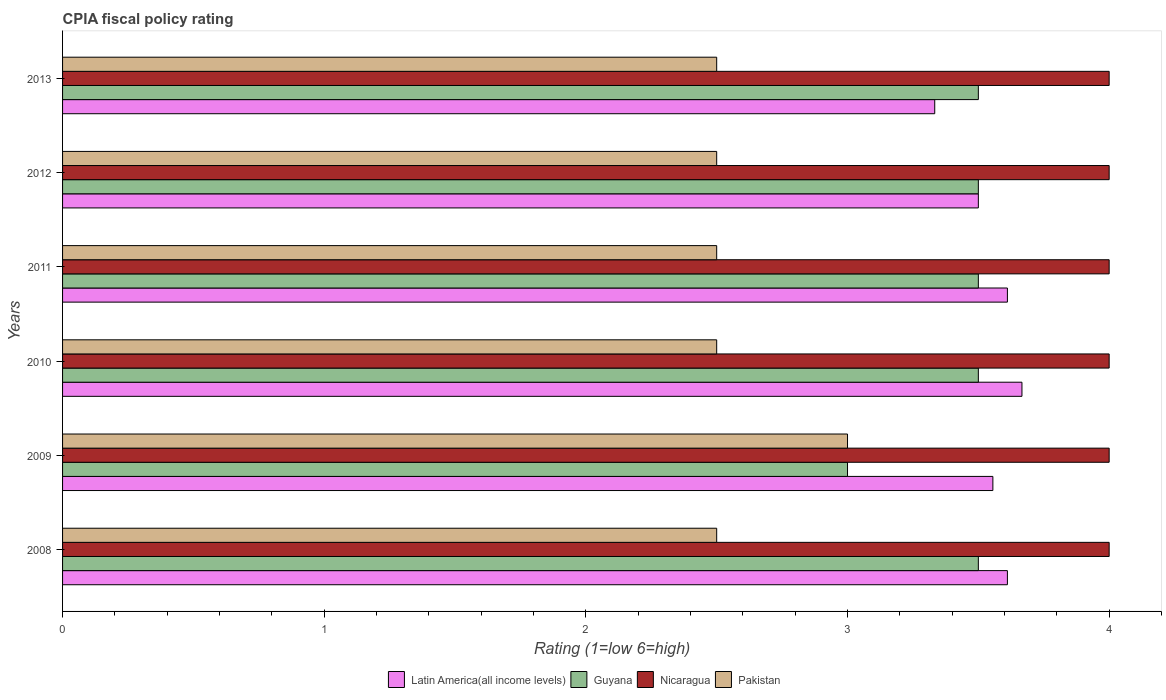Are the number of bars on each tick of the Y-axis equal?
Your response must be concise. Yes. How many bars are there on the 5th tick from the top?
Provide a short and direct response. 4. What is the label of the 4th group of bars from the top?
Provide a succinct answer. 2010. What is the CPIA rating in Guyana in 2010?
Provide a succinct answer. 3.5. Across all years, what is the minimum CPIA rating in Guyana?
Provide a short and direct response. 3. In which year was the CPIA rating in Pakistan maximum?
Offer a very short reply. 2009. In which year was the CPIA rating in Latin America(all income levels) minimum?
Offer a terse response. 2013. What is the difference between the CPIA rating in Nicaragua in 2008 and that in 2011?
Provide a succinct answer. 0. What is the difference between the CPIA rating in Latin America(all income levels) in 2009 and the CPIA rating in Pakistan in 2012?
Offer a terse response. 1.06. What is the average CPIA rating in Pakistan per year?
Your response must be concise. 2.58. In the year 2013, what is the difference between the CPIA rating in Guyana and CPIA rating in Pakistan?
Provide a short and direct response. 1. Is the CPIA rating in Guyana in 2009 less than that in 2011?
Keep it short and to the point. Yes. What is the difference between the highest and the second highest CPIA rating in Pakistan?
Offer a very short reply. 0.5. In how many years, is the CPIA rating in Nicaragua greater than the average CPIA rating in Nicaragua taken over all years?
Offer a terse response. 0. What does the 4th bar from the top in 2010 represents?
Make the answer very short. Latin America(all income levels). What does the 3rd bar from the bottom in 2013 represents?
Your response must be concise. Nicaragua. How many bars are there?
Your answer should be very brief. 24. Are all the bars in the graph horizontal?
Give a very brief answer. Yes. How many years are there in the graph?
Provide a short and direct response. 6. What is the difference between two consecutive major ticks on the X-axis?
Your answer should be compact. 1. Does the graph contain any zero values?
Offer a very short reply. No. Does the graph contain grids?
Your answer should be very brief. No. Where does the legend appear in the graph?
Offer a very short reply. Bottom center. How many legend labels are there?
Provide a succinct answer. 4. How are the legend labels stacked?
Provide a succinct answer. Horizontal. What is the title of the graph?
Your response must be concise. CPIA fiscal policy rating. Does "Dominican Republic" appear as one of the legend labels in the graph?
Your response must be concise. No. What is the label or title of the X-axis?
Your answer should be very brief. Rating (1=low 6=high). What is the Rating (1=low 6=high) of Latin America(all income levels) in 2008?
Your answer should be very brief. 3.61. What is the Rating (1=low 6=high) of Guyana in 2008?
Your answer should be compact. 3.5. What is the Rating (1=low 6=high) in Nicaragua in 2008?
Your response must be concise. 4. What is the Rating (1=low 6=high) in Pakistan in 2008?
Offer a very short reply. 2.5. What is the Rating (1=low 6=high) in Latin America(all income levels) in 2009?
Your response must be concise. 3.56. What is the Rating (1=low 6=high) of Guyana in 2009?
Provide a succinct answer. 3. What is the Rating (1=low 6=high) in Latin America(all income levels) in 2010?
Offer a very short reply. 3.67. What is the Rating (1=low 6=high) in Latin America(all income levels) in 2011?
Make the answer very short. 3.61. What is the Rating (1=low 6=high) in Guyana in 2011?
Provide a short and direct response. 3.5. What is the Rating (1=low 6=high) of Nicaragua in 2011?
Your response must be concise. 4. What is the Rating (1=low 6=high) in Pakistan in 2011?
Your answer should be compact. 2.5. What is the Rating (1=low 6=high) of Latin America(all income levels) in 2012?
Give a very brief answer. 3.5. What is the Rating (1=low 6=high) of Latin America(all income levels) in 2013?
Keep it short and to the point. 3.33. What is the Rating (1=low 6=high) in Guyana in 2013?
Ensure brevity in your answer.  3.5. What is the Rating (1=low 6=high) in Nicaragua in 2013?
Offer a very short reply. 4. What is the Rating (1=low 6=high) of Pakistan in 2013?
Make the answer very short. 2.5. Across all years, what is the maximum Rating (1=low 6=high) of Latin America(all income levels)?
Offer a terse response. 3.67. Across all years, what is the minimum Rating (1=low 6=high) of Latin America(all income levels)?
Provide a succinct answer. 3.33. Across all years, what is the minimum Rating (1=low 6=high) in Guyana?
Provide a short and direct response. 3. Across all years, what is the minimum Rating (1=low 6=high) of Nicaragua?
Provide a succinct answer. 4. Across all years, what is the minimum Rating (1=low 6=high) of Pakistan?
Ensure brevity in your answer.  2.5. What is the total Rating (1=low 6=high) of Latin America(all income levels) in the graph?
Give a very brief answer. 21.28. What is the difference between the Rating (1=low 6=high) in Latin America(all income levels) in 2008 and that in 2009?
Your answer should be compact. 0.06. What is the difference between the Rating (1=low 6=high) in Guyana in 2008 and that in 2009?
Provide a succinct answer. 0.5. What is the difference between the Rating (1=low 6=high) in Pakistan in 2008 and that in 2009?
Provide a succinct answer. -0.5. What is the difference between the Rating (1=low 6=high) of Latin America(all income levels) in 2008 and that in 2010?
Ensure brevity in your answer.  -0.06. What is the difference between the Rating (1=low 6=high) in Guyana in 2008 and that in 2010?
Your answer should be very brief. 0. What is the difference between the Rating (1=low 6=high) in Pakistan in 2008 and that in 2010?
Your response must be concise. 0. What is the difference between the Rating (1=low 6=high) in Latin America(all income levels) in 2008 and that in 2011?
Provide a succinct answer. 0. What is the difference between the Rating (1=low 6=high) of Latin America(all income levels) in 2008 and that in 2012?
Make the answer very short. 0.11. What is the difference between the Rating (1=low 6=high) of Guyana in 2008 and that in 2012?
Give a very brief answer. 0. What is the difference between the Rating (1=low 6=high) of Nicaragua in 2008 and that in 2012?
Your answer should be very brief. 0. What is the difference between the Rating (1=low 6=high) of Pakistan in 2008 and that in 2012?
Ensure brevity in your answer.  0. What is the difference between the Rating (1=low 6=high) in Latin America(all income levels) in 2008 and that in 2013?
Keep it short and to the point. 0.28. What is the difference between the Rating (1=low 6=high) of Nicaragua in 2008 and that in 2013?
Provide a succinct answer. 0. What is the difference between the Rating (1=low 6=high) in Latin America(all income levels) in 2009 and that in 2010?
Make the answer very short. -0.11. What is the difference between the Rating (1=low 6=high) in Pakistan in 2009 and that in 2010?
Keep it short and to the point. 0.5. What is the difference between the Rating (1=low 6=high) in Latin America(all income levels) in 2009 and that in 2011?
Ensure brevity in your answer.  -0.06. What is the difference between the Rating (1=low 6=high) in Guyana in 2009 and that in 2011?
Your answer should be very brief. -0.5. What is the difference between the Rating (1=low 6=high) of Nicaragua in 2009 and that in 2011?
Offer a very short reply. 0. What is the difference between the Rating (1=low 6=high) of Pakistan in 2009 and that in 2011?
Offer a very short reply. 0.5. What is the difference between the Rating (1=low 6=high) of Latin America(all income levels) in 2009 and that in 2012?
Provide a succinct answer. 0.06. What is the difference between the Rating (1=low 6=high) of Guyana in 2009 and that in 2012?
Ensure brevity in your answer.  -0.5. What is the difference between the Rating (1=low 6=high) of Nicaragua in 2009 and that in 2012?
Provide a short and direct response. 0. What is the difference between the Rating (1=low 6=high) of Pakistan in 2009 and that in 2012?
Make the answer very short. 0.5. What is the difference between the Rating (1=low 6=high) of Latin America(all income levels) in 2009 and that in 2013?
Provide a short and direct response. 0.22. What is the difference between the Rating (1=low 6=high) in Guyana in 2009 and that in 2013?
Offer a terse response. -0.5. What is the difference between the Rating (1=low 6=high) in Nicaragua in 2009 and that in 2013?
Keep it short and to the point. 0. What is the difference between the Rating (1=low 6=high) of Pakistan in 2009 and that in 2013?
Provide a short and direct response. 0.5. What is the difference between the Rating (1=low 6=high) in Latin America(all income levels) in 2010 and that in 2011?
Provide a succinct answer. 0.06. What is the difference between the Rating (1=low 6=high) in Guyana in 2010 and that in 2011?
Offer a terse response. 0. What is the difference between the Rating (1=low 6=high) of Nicaragua in 2010 and that in 2011?
Offer a very short reply. 0. What is the difference between the Rating (1=low 6=high) of Latin America(all income levels) in 2010 and that in 2012?
Your response must be concise. 0.17. What is the difference between the Rating (1=low 6=high) of Nicaragua in 2010 and that in 2012?
Offer a terse response. 0. What is the difference between the Rating (1=low 6=high) of Guyana in 2010 and that in 2013?
Your answer should be compact. 0. What is the difference between the Rating (1=low 6=high) of Nicaragua in 2010 and that in 2013?
Make the answer very short. 0. What is the difference between the Rating (1=low 6=high) in Latin America(all income levels) in 2011 and that in 2012?
Your answer should be compact. 0.11. What is the difference between the Rating (1=low 6=high) of Guyana in 2011 and that in 2012?
Make the answer very short. 0. What is the difference between the Rating (1=low 6=high) of Pakistan in 2011 and that in 2012?
Provide a succinct answer. 0. What is the difference between the Rating (1=low 6=high) of Latin America(all income levels) in 2011 and that in 2013?
Your answer should be compact. 0.28. What is the difference between the Rating (1=low 6=high) in Guyana in 2011 and that in 2013?
Provide a short and direct response. 0. What is the difference between the Rating (1=low 6=high) in Pakistan in 2011 and that in 2013?
Keep it short and to the point. 0. What is the difference between the Rating (1=low 6=high) in Latin America(all income levels) in 2012 and that in 2013?
Make the answer very short. 0.17. What is the difference between the Rating (1=low 6=high) of Guyana in 2012 and that in 2013?
Ensure brevity in your answer.  0. What is the difference between the Rating (1=low 6=high) in Latin America(all income levels) in 2008 and the Rating (1=low 6=high) in Guyana in 2009?
Offer a very short reply. 0.61. What is the difference between the Rating (1=low 6=high) in Latin America(all income levels) in 2008 and the Rating (1=low 6=high) in Nicaragua in 2009?
Provide a short and direct response. -0.39. What is the difference between the Rating (1=low 6=high) in Latin America(all income levels) in 2008 and the Rating (1=low 6=high) in Pakistan in 2009?
Your answer should be compact. 0.61. What is the difference between the Rating (1=low 6=high) of Latin America(all income levels) in 2008 and the Rating (1=low 6=high) of Nicaragua in 2010?
Your answer should be very brief. -0.39. What is the difference between the Rating (1=low 6=high) of Latin America(all income levels) in 2008 and the Rating (1=low 6=high) of Pakistan in 2010?
Provide a short and direct response. 1.11. What is the difference between the Rating (1=low 6=high) of Nicaragua in 2008 and the Rating (1=low 6=high) of Pakistan in 2010?
Your answer should be very brief. 1.5. What is the difference between the Rating (1=low 6=high) of Latin America(all income levels) in 2008 and the Rating (1=low 6=high) of Guyana in 2011?
Your response must be concise. 0.11. What is the difference between the Rating (1=low 6=high) in Latin America(all income levels) in 2008 and the Rating (1=low 6=high) in Nicaragua in 2011?
Make the answer very short. -0.39. What is the difference between the Rating (1=low 6=high) in Latin America(all income levels) in 2008 and the Rating (1=low 6=high) in Pakistan in 2011?
Offer a terse response. 1.11. What is the difference between the Rating (1=low 6=high) of Latin America(all income levels) in 2008 and the Rating (1=low 6=high) of Guyana in 2012?
Offer a very short reply. 0.11. What is the difference between the Rating (1=low 6=high) in Latin America(all income levels) in 2008 and the Rating (1=low 6=high) in Nicaragua in 2012?
Provide a succinct answer. -0.39. What is the difference between the Rating (1=low 6=high) in Latin America(all income levels) in 2008 and the Rating (1=low 6=high) in Pakistan in 2012?
Provide a short and direct response. 1.11. What is the difference between the Rating (1=low 6=high) of Nicaragua in 2008 and the Rating (1=low 6=high) of Pakistan in 2012?
Your response must be concise. 1.5. What is the difference between the Rating (1=low 6=high) in Latin America(all income levels) in 2008 and the Rating (1=low 6=high) in Guyana in 2013?
Your response must be concise. 0.11. What is the difference between the Rating (1=low 6=high) in Latin America(all income levels) in 2008 and the Rating (1=low 6=high) in Nicaragua in 2013?
Offer a very short reply. -0.39. What is the difference between the Rating (1=low 6=high) in Latin America(all income levels) in 2008 and the Rating (1=low 6=high) in Pakistan in 2013?
Provide a succinct answer. 1.11. What is the difference between the Rating (1=low 6=high) of Latin America(all income levels) in 2009 and the Rating (1=low 6=high) of Guyana in 2010?
Keep it short and to the point. 0.06. What is the difference between the Rating (1=low 6=high) in Latin America(all income levels) in 2009 and the Rating (1=low 6=high) in Nicaragua in 2010?
Give a very brief answer. -0.44. What is the difference between the Rating (1=low 6=high) in Latin America(all income levels) in 2009 and the Rating (1=low 6=high) in Pakistan in 2010?
Your response must be concise. 1.06. What is the difference between the Rating (1=low 6=high) of Nicaragua in 2009 and the Rating (1=low 6=high) of Pakistan in 2010?
Offer a terse response. 1.5. What is the difference between the Rating (1=low 6=high) in Latin America(all income levels) in 2009 and the Rating (1=low 6=high) in Guyana in 2011?
Your response must be concise. 0.06. What is the difference between the Rating (1=low 6=high) of Latin America(all income levels) in 2009 and the Rating (1=low 6=high) of Nicaragua in 2011?
Your answer should be compact. -0.44. What is the difference between the Rating (1=low 6=high) of Latin America(all income levels) in 2009 and the Rating (1=low 6=high) of Pakistan in 2011?
Offer a terse response. 1.06. What is the difference between the Rating (1=low 6=high) in Guyana in 2009 and the Rating (1=low 6=high) in Pakistan in 2011?
Your answer should be very brief. 0.5. What is the difference between the Rating (1=low 6=high) of Nicaragua in 2009 and the Rating (1=low 6=high) of Pakistan in 2011?
Offer a terse response. 1.5. What is the difference between the Rating (1=low 6=high) in Latin America(all income levels) in 2009 and the Rating (1=low 6=high) in Guyana in 2012?
Provide a succinct answer. 0.06. What is the difference between the Rating (1=low 6=high) of Latin America(all income levels) in 2009 and the Rating (1=low 6=high) of Nicaragua in 2012?
Your answer should be compact. -0.44. What is the difference between the Rating (1=low 6=high) of Latin America(all income levels) in 2009 and the Rating (1=low 6=high) of Pakistan in 2012?
Make the answer very short. 1.06. What is the difference between the Rating (1=low 6=high) in Guyana in 2009 and the Rating (1=low 6=high) in Pakistan in 2012?
Give a very brief answer. 0.5. What is the difference between the Rating (1=low 6=high) of Latin America(all income levels) in 2009 and the Rating (1=low 6=high) of Guyana in 2013?
Offer a very short reply. 0.06. What is the difference between the Rating (1=low 6=high) of Latin America(all income levels) in 2009 and the Rating (1=low 6=high) of Nicaragua in 2013?
Offer a terse response. -0.44. What is the difference between the Rating (1=low 6=high) in Latin America(all income levels) in 2009 and the Rating (1=low 6=high) in Pakistan in 2013?
Your answer should be very brief. 1.06. What is the difference between the Rating (1=low 6=high) in Guyana in 2009 and the Rating (1=low 6=high) in Pakistan in 2013?
Your response must be concise. 0.5. What is the difference between the Rating (1=low 6=high) of Latin America(all income levels) in 2010 and the Rating (1=low 6=high) of Nicaragua in 2011?
Provide a short and direct response. -0.33. What is the difference between the Rating (1=low 6=high) of Latin America(all income levels) in 2010 and the Rating (1=low 6=high) of Pakistan in 2011?
Provide a short and direct response. 1.17. What is the difference between the Rating (1=low 6=high) in Guyana in 2010 and the Rating (1=low 6=high) in Nicaragua in 2011?
Ensure brevity in your answer.  -0.5. What is the difference between the Rating (1=low 6=high) of Guyana in 2010 and the Rating (1=low 6=high) of Pakistan in 2011?
Offer a terse response. 1. What is the difference between the Rating (1=low 6=high) of Latin America(all income levels) in 2010 and the Rating (1=low 6=high) of Guyana in 2012?
Ensure brevity in your answer.  0.17. What is the difference between the Rating (1=low 6=high) in Latin America(all income levels) in 2010 and the Rating (1=low 6=high) in Nicaragua in 2012?
Offer a very short reply. -0.33. What is the difference between the Rating (1=low 6=high) of Latin America(all income levels) in 2010 and the Rating (1=low 6=high) of Pakistan in 2012?
Make the answer very short. 1.17. What is the difference between the Rating (1=low 6=high) in Guyana in 2010 and the Rating (1=low 6=high) in Pakistan in 2012?
Keep it short and to the point. 1. What is the difference between the Rating (1=low 6=high) in Nicaragua in 2010 and the Rating (1=low 6=high) in Pakistan in 2012?
Make the answer very short. 1.5. What is the difference between the Rating (1=low 6=high) in Latin America(all income levels) in 2010 and the Rating (1=low 6=high) in Nicaragua in 2013?
Offer a very short reply. -0.33. What is the difference between the Rating (1=low 6=high) in Guyana in 2010 and the Rating (1=low 6=high) in Nicaragua in 2013?
Offer a very short reply. -0.5. What is the difference between the Rating (1=low 6=high) in Latin America(all income levels) in 2011 and the Rating (1=low 6=high) in Guyana in 2012?
Offer a terse response. 0.11. What is the difference between the Rating (1=low 6=high) in Latin America(all income levels) in 2011 and the Rating (1=low 6=high) in Nicaragua in 2012?
Make the answer very short. -0.39. What is the difference between the Rating (1=low 6=high) of Guyana in 2011 and the Rating (1=low 6=high) of Nicaragua in 2012?
Offer a very short reply. -0.5. What is the difference between the Rating (1=low 6=high) in Guyana in 2011 and the Rating (1=low 6=high) in Pakistan in 2012?
Make the answer very short. 1. What is the difference between the Rating (1=low 6=high) in Latin America(all income levels) in 2011 and the Rating (1=low 6=high) in Guyana in 2013?
Make the answer very short. 0.11. What is the difference between the Rating (1=low 6=high) in Latin America(all income levels) in 2011 and the Rating (1=low 6=high) in Nicaragua in 2013?
Offer a terse response. -0.39. What is the difference between the Rating (1=low 6=high) of Guyana in 2011 and the Rating (1=low 6=high) of Nicaragua in 2013?
Provide a short and direct response. -0.5. What is the difference between the Rating (1=low 6=high) of Guyana in 2011 and the Rating (1=low 6=high) of Pakistan in 2013?
Provide a succinct answer. 1. What is the difference between the Rating (1=low 6=high) of Latin America(all income levels) in 2012 and the Rating (1=low 6=high) of Pakistan in 2013?
Ensure brevity in your answer.  1. What is the difference between the Rating (1=low 6=high) in Guyana in 2012 and the Rating (1=low 6=high) in Nicaragua in 2013?
Your answer should be compact. -0.5. What is the difference between the Rating (1=low 6=high) of Nicaragua in 2012 and the Rating (1=low 6=high) of Pakistan in 2013?
Offer a very short reply. 1.5. What is the average Rating (1=low 6=high) of Latin America(all income levels) per year?
Ensure brevity in your answer.  3.55. What is the average Rating (1=low 6=high) of Guyana per year?
Provide a succinct answer. 3.42. What is the average Rating (1=low 6=high) of Pakistan per year?
Ensure brevity in your answer.  2.58. In the year 2008, what is the difference between the Rating (1=low 6=high) of Latin America(all income levels) and Rating (1=low 6=high) of Guyana?
Offer a terse response. 0.11. In the year 2008, what is the difference between the Rating (1=low 6=high) in Latin America(all income levels) and Rating (1=low 6=high) in Nicaragua?
Your answer should be very brief. -0.39. In the year 2008, what is the difference between the Rating (1=low 6=high) of Guyana and Rating (1=low 6=high) of Pakistan?
Your answer should be compact. 1. In the year 2008, what is the difference between the Rating (1=low 6=high) in Nicaragua and Rating (1=low 6=high) in Pakistan?
Provide a succinct answer. 1.5. In the year 2009, what is the difference between the Rating (1=low 6=high) of Latin America(all income levels) and Rating (1=low 6=high) of Guyana?
Your answer should be very brief. 0.56. In the year 2009, what is the difference between the Rating (1=low 6=high) in Latin America(all income levels) and Rating (1=low 6=high) in Nicaragua?
Your response must be concise. -0.44. In the year 2009, what is the difference between the Rating (1=low 6=high) of Latin America(all income levels) and Rating (1=low 6=high) of Pakistan?
Provide a succinct answer. 0.56. In the year 2009, what is the difference between the Rating (1=low 6=high) of Guyana and Rating (1=low 6=high) of Nicaragua?
Offer a very short reply. -1. In the year 2009, what is the difference between the Rating (1=low 6=high) in Nicaragua and Rating (1=low 6=high) in Pakistan?
Keep it short and to the point. 1. In the year 2011, what is the difference between the Rating (1=low 6=high) of Latin America(all income levels) and Rating (1=low 6=high) of Nicaragua?
Offer a terse response. -0.39. In the year 2011, what is the difference between the Rating (1=low 6=high) in Latin America(all income levels) and Rating (1=low 6=high) in Pakistan?
Your answer should be very brief. 1.11. In the year 2011, what is the difference between the Rating (1=low 6=high) in Guyana and Rating (1=low 6=high) in Nicaragua?
Your answer should be compact. -0.5. In the year 2012, what is the difference between the Rating (1=low 6=high) of Latin America(all income levels) and Rating (1=low 6=high) of Pakistan?
Ensure brevity in your answer.  1. In the year 2012, what is the difference between the Rating (1=low 6=high) of Guyana and Rating (1=low 6=high) of Nicaragua?
Your answer should be compact. -0.5. In the year 2013, what is the difference between the Rating (1=low 6=high) in Latin America(all income levels) and Rating (1=low 6=high) in Guyana?
Your answer should be very brief. -0.17. In the year 2013, what is the difference between the Rating (1=low 6=high) of Latin America(all income levels) and Rating (1=low 6=high) of Pakistan?
Your response must be concise. 0.83. What is the ratio of the Rating (1=low 6=high) of Latin America(all income levels) in 2008 to that in 2009?
Keep it short and to the point. 1.02. What is the ratio of the Rating (1=low 6=high) in Guyana in 2008 to that in 2009?
Offer a terse response. 1.17. What is the ratio of the Rating (1=low 6=high) in Nicaragua in 2008 to that in 2009?
Give a very brief answer. 1. What is the ratio of the Rating (1=low 6=high) of Latin America(all income levels) in 2008 to that in 2010?
Offer a very short reply. 0.98. What is the ratio of the Rating (1=low 6=high) of Pakistan in 2008 to that in 2010?
Your answer should be very brief. 1. What is the ratio of the Rating (1=low 6=high) of Guyana in 2008 to that in 2011?
Keep it short and to the point. 1. What is the ratio of the Rating (1=low 6=high) in Nicaragua in 2008 to that in 2011?
Your response must be concise. 1. What is the ratio of the Rating (1=low 6=high) of Latin America(all income levels) in 2008 to that in 2012?
Give a very brief answer. 1.03. What is the ratio of the Rating (1=low 6=high) of Guyana in 2008 to that in 2012?
Provide a short and direct response. 1. What is the ratio of the Rating (1=low 6=high) in Nicaragua in 2008 to that in 2012?
Provide a succinct answer. 1. What is the ratio of the Rating (1=low 6=high) of Pakistan in 2008 to that in 2012?
Your answer should be compact. 1. What is the ratio of the Rating (1=low 6=high) in Latin America(all income levels) in 2009 to that in 2010?
Your answer should be very brief. 0.97. What is the ratio of the Rating (1=low 6=high) in Pakistan in 2009 to that in 2010?
Ensure brevity in your answer.  1.2. What is the ratio of the Rating (1=low 6=high) of Latin America(all income levels) in 2009 to that in 2011?
Your answer should be very brief. 0.98. What is the ratio of the Rating (1=low 6=high) in Guyana in 2009 to that in 2011?
Provide a succinct answer. 0.86. What is the ratio of the Rating (1=low 6=high) of Nicaragua in 2009 to that in 2011?
Provide a succinct answer. 1. What is the ratio of the Rating (1=low 6=high) of Latin America(all income levels) in 2009 to that in 2012?
Provide a short and direct response. 1.02. What is the ratio of the Rating (1=low 6=high) in Guyana in 2009 to that in 2012?
Provide a short and direct response. 0.86. What is the ratio of the Rating (1=low 6=high) in Latin America(all income levels) in 2009 to that in 2013?
Provide a short and direct response. 1.07. What is the ratio of the Rating (1=low 6=high) of Guyana in 2009 to that in 2013?
Give a very brief answer. 0.86. What is the ratio of the Rating (1=low 6=high) in Pakistan in 2009 to that in 2013?
Ensure brevity in your answer.  1.2. What is the ratio of the Rating (1=low 6=high) of Latin America(all income levels) in 2010 to that in 2011?
Provide a succinct answer. 1.02. What is the ratio of the Rating (1=low 6=high) of Guyana in 2010 to that in 2011?
Your answer should be compact. 1. What is the ratio of the Rating (1=low 6=high) in Latin America(all income levels) in 2010 to that in 2012?
Give a very brief answer. 1.05. What is the ratio of the Rating (1=low 6=high) in Guyana in 2010 to that in 2012?
Offer a terse response. 1. What is the ratio of the Rating (1=low 6=high) of Guyana in 2010 to that in 2013?
Offer a very short reply. 1. What is the ratio of the Rating (1=low 6=high) in Nicaragua in 2010 to that in 2013?
Provide a succinct answer. 1. What is the ratio of the Rating (1=low 6=high) of Latin America(all income levels) in 2011 to that in 2012?
Your answer should be compact. 1.03. What is the ratio of the Rating (1=low 6=high) in Guyana in 2011 to that in 2012?
Make the answer very short. 1. What is the ratio of the Rating (1=low 6=high) of Pakistan in 2011 to that in 2012?
Your answer should be very brief. 1. What is the ratio of the Rating (1=low 6=high) of Guyana in 2011 to that in 2013?
Your answer should be compact. 1. What is the ratio of the Rating (1=low 6=high) in Nicaragua in 2011 to that in 2013?
Ensure brevity in your answer.  1. What is the ratio of the Rating (1=low 6=high) of Pakistan in 2011 to that in 2013?
Make the answer very short. 1. What is the ratio of the Rating (1=low 6=high) of Nicaragua in 2012 to that in 2013?
Your answer should be compact. 1. What is the difference between the highest and the second highest Rating (1=low 6=high) of Latin America(all income levels)?
Provide a short and direct response. 0.06. What is the difference between the highest and the second highest Rating (1=low 6=high) of Guyana?
Provide a short and direct response. 0. What is the difference between the highest and the second highest Rating (1=low 6=high) in Nicaragua?
Keep it short and to the point. 0. What is the difference between the highest and the lowest Rating (1=low 6=high) in Nicaragua?
Offer a very short reply. 0. 